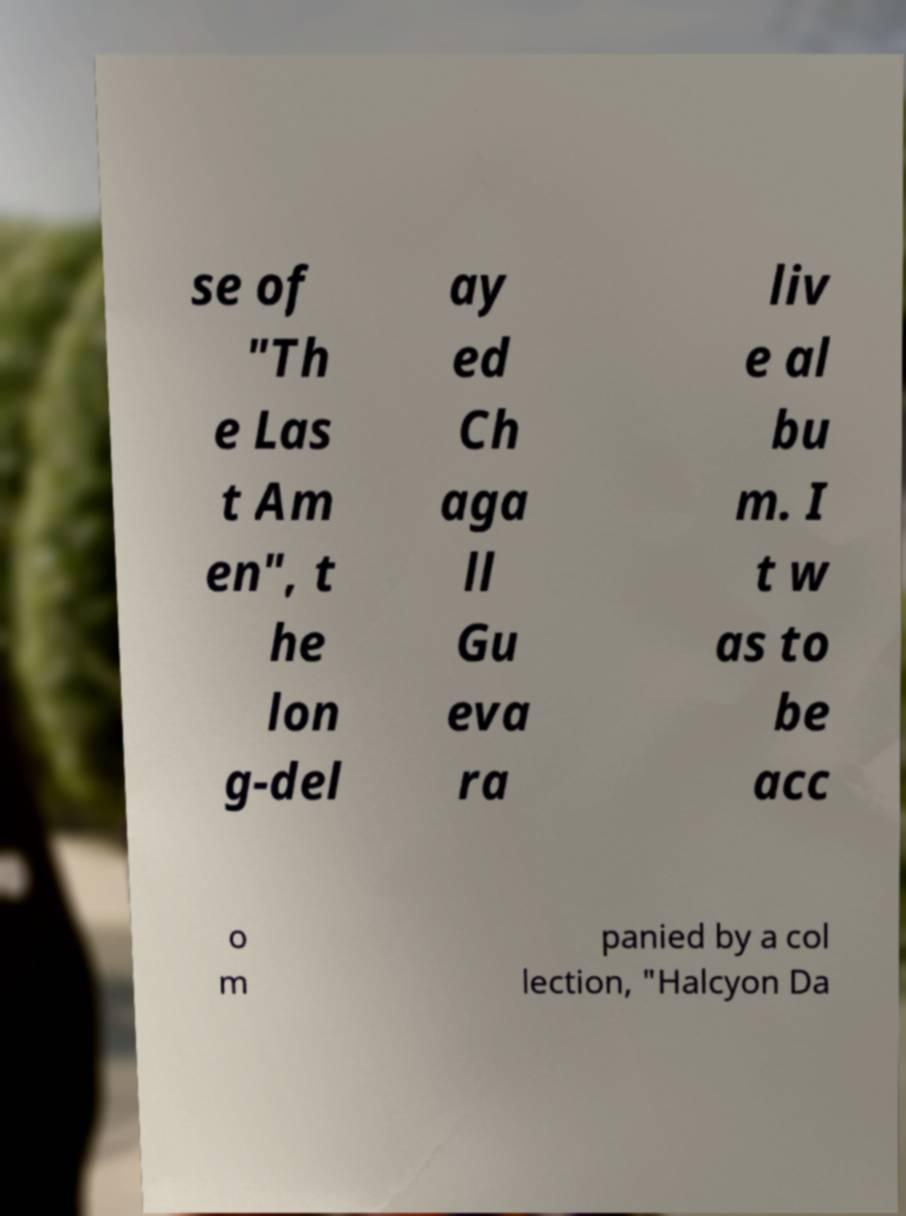Could you extract and type out the text from this image? se of "Th e Las t Am en", t he lon g-del ay ed Ch aga ll Gu eva ra liv e al bu m. I t w as to be acc o m panied by a col lection, "Halcyon Da 